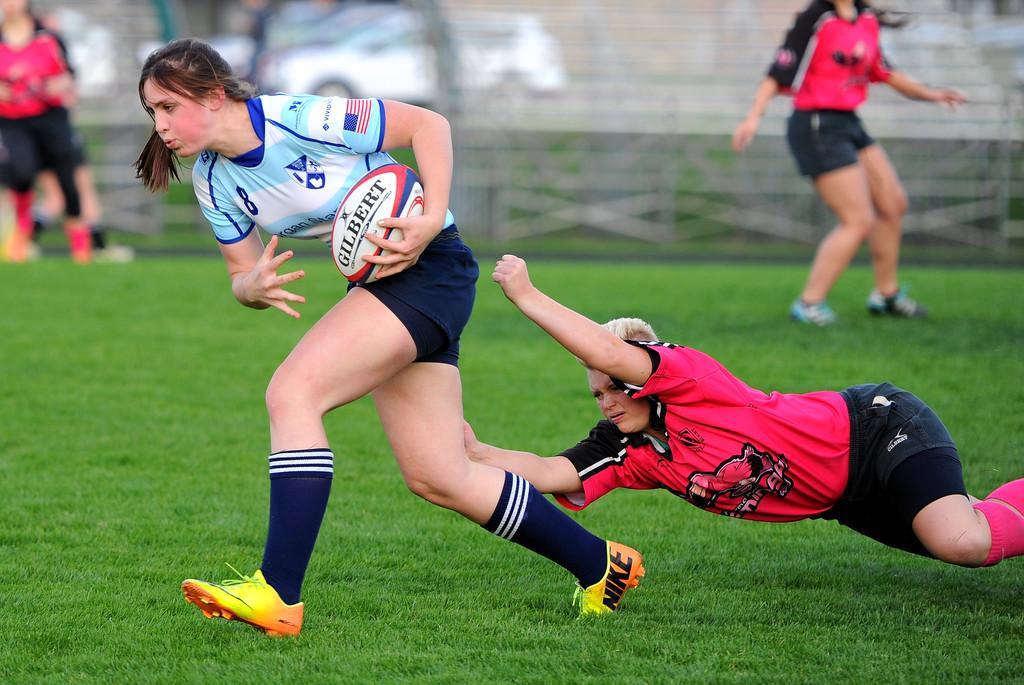Could you give a brief overview of what you see in this image? In this image i can see few persons playing game there is a ball in the image a woman wearing a blue jersey at the back ground i can see a wall. 